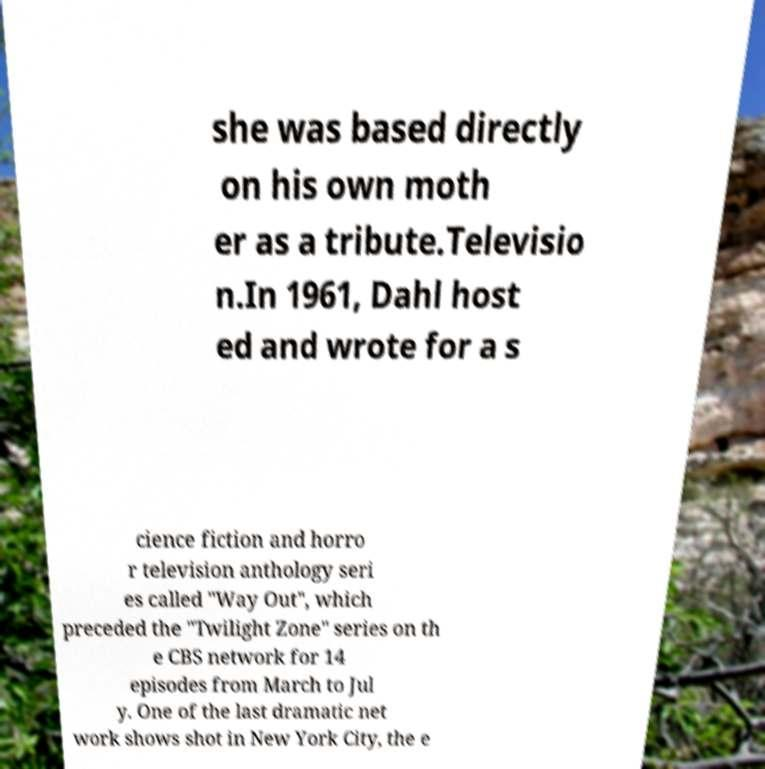Could you assist in decoding the text presented in this image and type it out clearly? she was based directly on his own moth er as a tribute.Televisio n.In 1961, Dahl host ed and wrote for a s cience fiction and horro r television anthology seri es called "Way Out", which preceded the "Twilight Zone" series on th e CBS network for 14 episodes from March to Jul y. One of the last dramatic net work shows shot in New York City, the e 